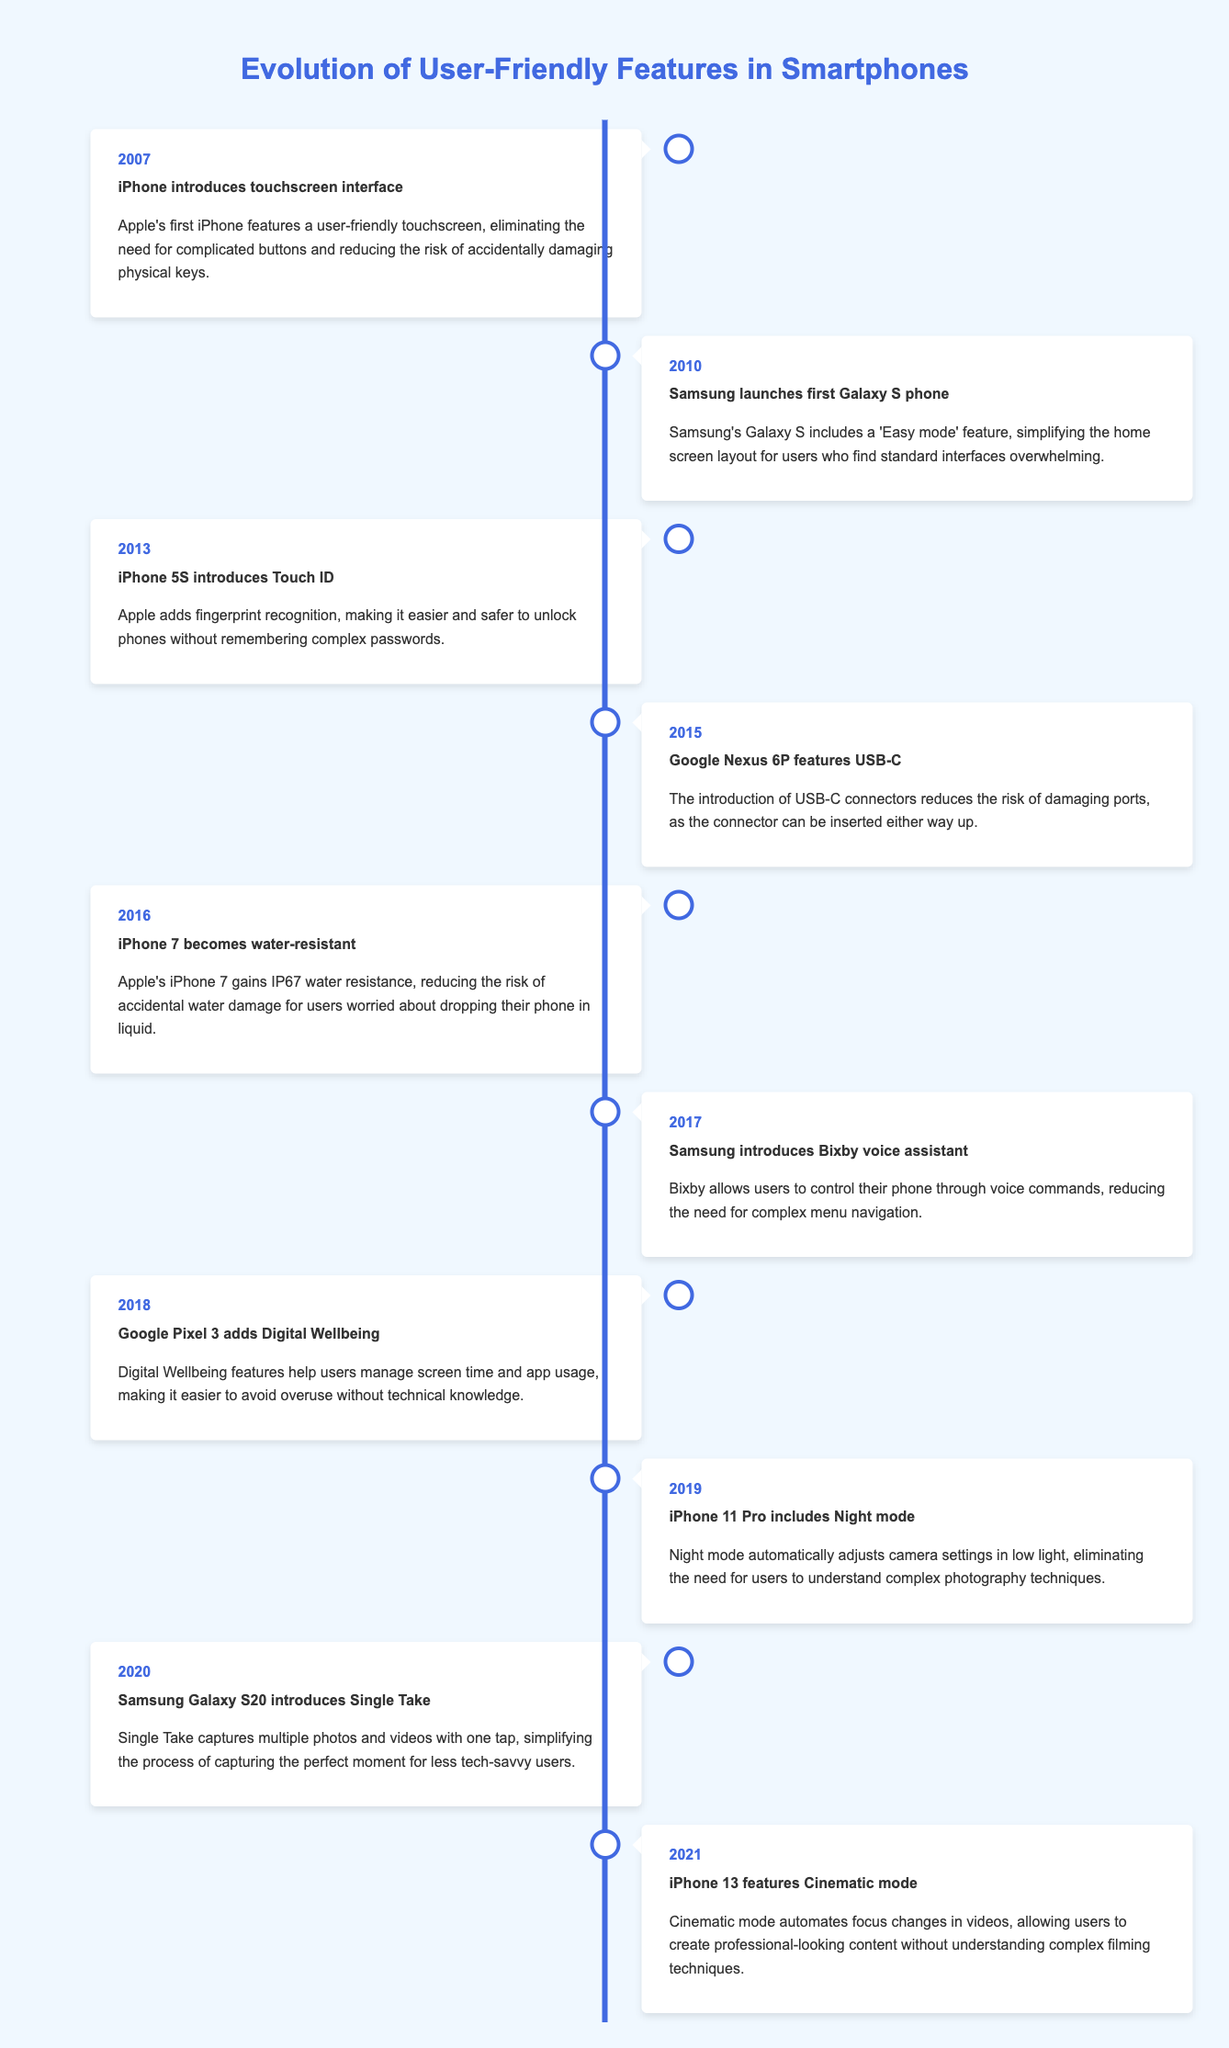What year did the iPhone first introduce the touchscreen interface? The table states that the event of the iPhone introducing a touchscreen interface occurred in the year 2007.
Answer: 2007 What major feature was added to the iPhone 5S in 2013? According to the table, the iPhone 5S introduced the Touch ID feature, which allows users to unlock their phones with their fingerprint.
Answer: Touch ID Which smartphone became water-resistant in 2016? The table indicates that the iPhone 7 gained water resistance in 2016, marked as IP67 certification.
Answer: iPhone 7 How many years apart were the introductions of Easy mode and Digital Wellbeing features? Easy mode was introduced in 2010 and Digital Wellbeing in 2018. The difference in years is 2018 - 2010 = 8 years.
Answer: 8 years Did the Samsung Galaxy S20 introduce a feature that simplifies capturing photos? The event for Samsung Galaxy S20 in 2020 describes a feature called Single Take that captures multiple photos and videos with one tap, thus simplifying the process. Therefore, the statement is true.
Answer: Yes What was the main benefit of the USB-C feature introduced in 2015? The table explains that USB-C can be inserted either way, reducing the risk of damaging ports. This implies that the main benefit is ease of use without worrying about damaging connections.
Answer: Reduces risk of damaging ports What features were introduced by Apple in consecutive years 2013 and 2015? In 2013, Apple introduced Touch ID (iPhone 5S), and in 2015, USB-C was introduced with Google Nexus 6P. Hence, the two features are not from Apple for 2015, but rather from Google. The answer must reflect that only Touch ID is from Apple.
Answer: Touch ID Which notable feature helped users avoid overuse without technical knowledge? The timeline notes that Digital Wellbeing features in 2018 were designed to help manage screen time and app usage, which indicates ease of use for non-technical users.
Answer: Digital Wellbeing In what year did Samsung introduce Bixby voice assistant? The table shows that Samsung introduced the Bixby voice assistant in the year 2017.
Answer: 2017 